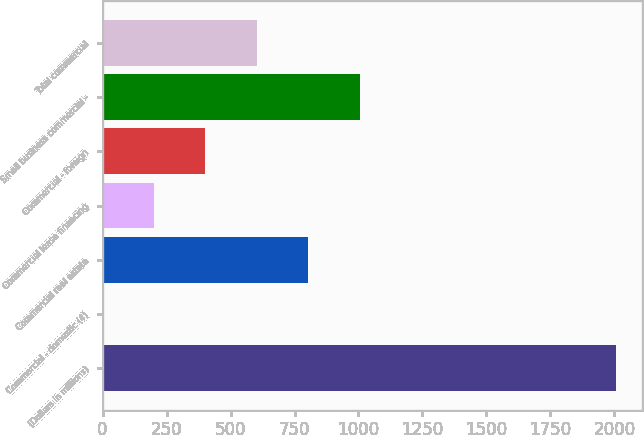<chart> <loc_0><loc_0><loc_500><loc_500><bar_chart><fcel>(Dollars in millions)<fcel>Commercial - domestic (4)<fcel>Commercial real estate<fcel>Commercial lease financing<fcel>Commercial - foreign<fcel>Small business commercial -<fcel>Total commercial<nl><fcel>2008<fcel>0.26<fcel>803.34<fcel>201.03<fcel>401.8<fcel>1004.11<fcel>602.57<nl></chart> 